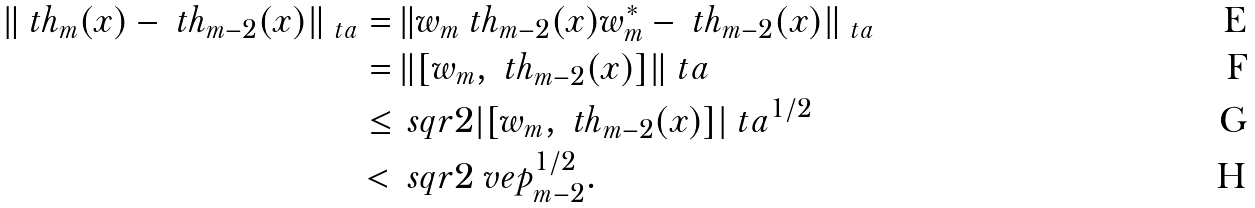Convert formula to latex. <formula><loc_0><loc_0><loc_500><loc_500>\| \ t h _ { m } ( x ) - \ t h _ { m - 2 } ( x ) \| _ { \ t a } = & \, \| w _ { m } \ t h _ { m - 2 } ( x ) w _ { m } ^ { * } - \ t h _ { m - 2 } ( x ) \| _ { \ t a } \\ = & \, \| [ w _ { m } , \ t h _ { m - 2 } ( x ) ] \| _ { \ } t a \\ \leq & \, \ s q r { 2 } | [ w _ { m } , \ t h _ { m - 2 } ( x ) ] | _ { \ } t a ^ { 1 / 2 } \\ < & \, \ s q r { 2 } \ v e p _ { m - 2 } ^ { 1 / 2 } .</formula> 